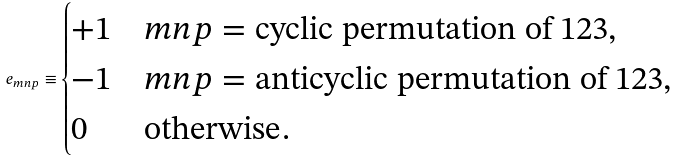Convert formula to latex. <formula><loc_0><loc_0><loc_500><loc_500>\ e _ { m n p } \equiv \begin{cases} + 1 & m n p = \text {cyclic permutation of 123,} \\ - 1 & m n p = \text {anticyclic permutation of 123,} \\ 0 & \text {otherwise} . \end{cases}</formula> 